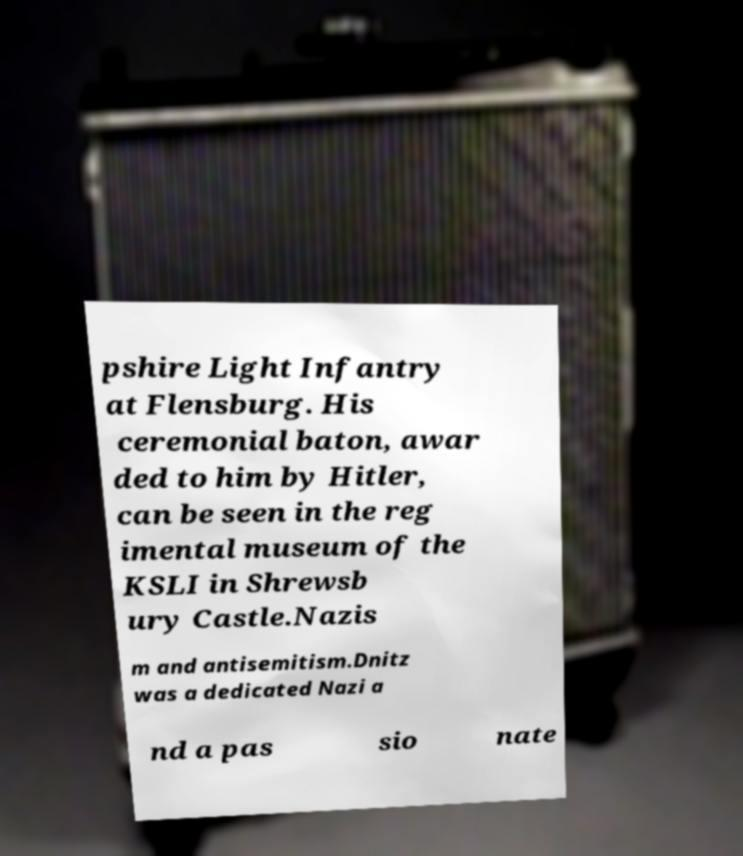Can you read and provide the text displayed in the image?This photo seems to have some interesting text. Can you extract and type it out for me? pshire Light Infantry at Flensburg. His ceremonial baton, awar ded to him by Hitler, can be seen in the reg imental museum of the KSLI in Shrewsb ury Castle.Nazis m and antisemitism.Dnitz was a dedicated Nazi a nd a pas sio nate 